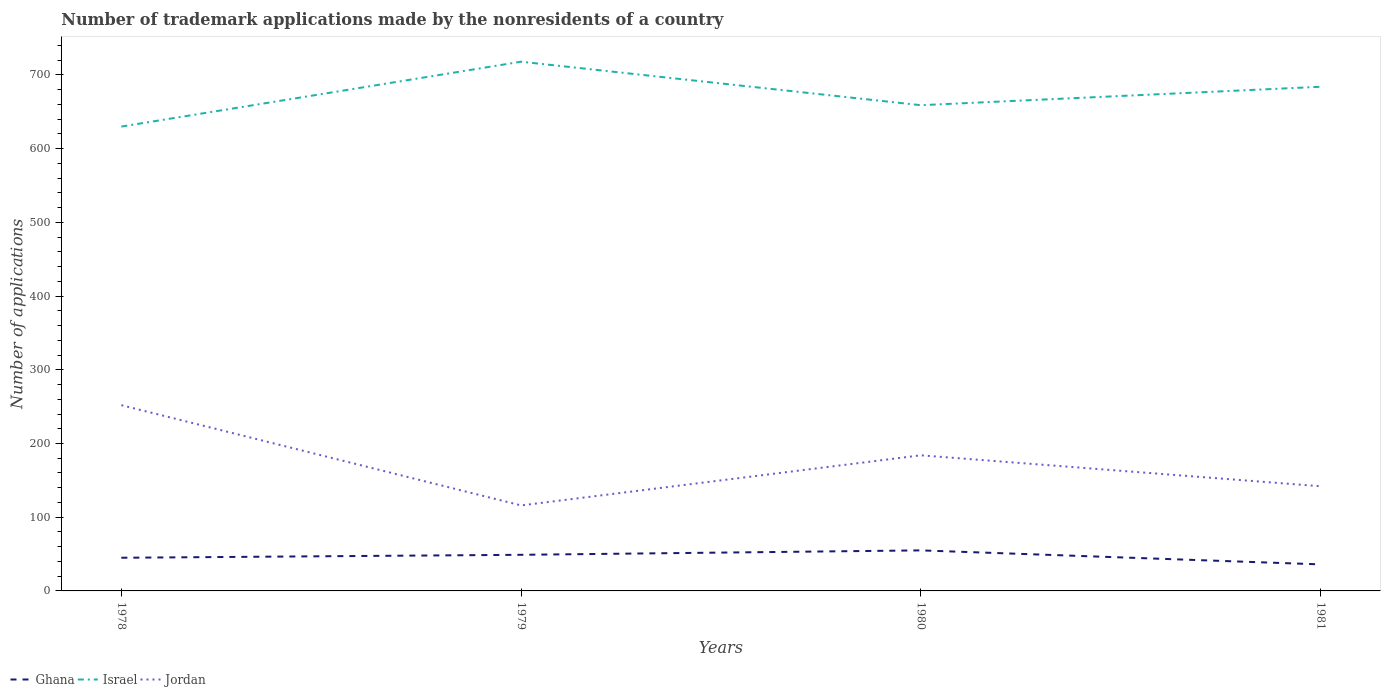How many different coloured lines are there?
Your answer should be compact. 3. Is the number of lines equal to the number of legend labels?
Give a very brief answer. Yes. In which year was the number of trademark applications made by the nonresidents in Israel maximum?
Give a very brief answer. 1978. What is the total number of trademark applications made by the nonresidents in Jordan in the graph?
Provide a short and direct response. -68. What is the difference between the highest and the lowest number of trademark applications made by the nonresidents in Ghana?
Offer a very short reply. 2. Is the number of trademark applications made by the nonresidents in Jordan strictly greater than the number of trademark applications made by the nonresidents in Ghana over the years?
Offer a terse response. No. How many lines are there?
Provide a short and direct response. 3. What is the difference between two consecutive major ticks on the Y-axis?
Your answer should be compact. 100. Does the graph contain any zero values?
Your answer should be very brief. No. Where does the legend appear in the graph?
Your answer should be very brief. Bottom left. What is the title of the graph?
Your response must be concise. Number of trademark applications made by the nonresidents of a country. What is the label or title of the Y-axis?
Provide a short and direct response. Number of applications. What is the Number of applications of Israel in 1978?
Your answer should be compact. 630. What is the Number of applications in Jordan in 1978?
Keep it short and to the point. 252. What is the Number of applications in Israel in 1979?
Your response must be concise. 718. What is the Number of applications in Jordan in 1979?
Keep it short and to the point. 116. What is the Number of applications in Israel in 1980?
Your answer should be very brief. 659. What is the Number of applications of Jordan in 1980?
Give a very brief answer. 184. What is the Number of applications in Israel in 1981?
Offer a terse response. 684. What is the Number of applications of Jordan in 1981?
Your response must be concise. 142. Across all years, what is the maximum Number of applications in Ghana?
Provide a short and direct response. 55. Across all years, what is the maximum Number of applications in Israel?
Keep it short and to the point. 718. Across all years, what is the maximum Number of applications in Jordan?
Provide a succinct answer. 252. Across all years, what is the minimum Number of applications in Israel?
Offer a terse response. 630. Across all years, what is the minimum Number of applications in Jordan?
Your answer should be very brief. 116. What is the total Number of applications in Ghana in the graph?
Provide a succinct answer. 185. What is the total Number of applications of Israel in the graph?
Your response must be concise. 2691. What is the total Number of applications of Jordan in the graph?
Offer a very short reply. 694. What is the difference between the Number of applications in Israel in 1978 and that in 1979?
Keep it short and to the point. -88. What is the difference between the Number of applications in Jordan in 1978 and that in 1979?
Your response must be concise. 136. What is the difference between the Number of applications in Ghana in 1978 and that in 1980?
Provide a short and direct response. -10. What is the difference between the Number of applications of Israel in 1978 and that in 1980?
Ensure brevity in your answer.  -29. What is the difference between the Number of applications of Israel in 1978 and that in 1981?
Your response must be concise. -54. What is the difference between the Number of applications in Jordan in 1978 and that in 1981?
Keep it short and to the point. 110. What is the difference between the Number of applications in Israel in 1979 and that in 1980?
Keep it short and to the point. 59. What is the difference between the Number of applications in Jordan in 1979 and that in 1980?
Make the answer very short. -68. What is the difference between the Number of applications in Ghana in 1979 and that in 1981?
Give a very brief answer. 13. What is the difference between the Number of applications in Israel in 1979 and that in 1981?
Your response must be concise. 34. What is the difference between the Number of applications of Jordan in 1979 and that in 1981?
Your answer should be compact. -26. What is the difference between the Number of applications in Ghana in 1978 and the Number of applications in Israel in 1979?
Give a very brief answer. -673. What is the difference between the Number of applications of Ghana in 1978 and the Number of applications of Jordan in 1979?
Your answer should be very brief. -71. What is the difference between the Number of applications of Israel in 1978 and the Number of applications of Jordan in 1979?
Your answer should be compact. 514. What is the difference between the Number of applications of Ghana in 1978 and the Number of applications of Israel in 1980?
Give a very brief answer. -614. What is the difference between the Number of applications in Ghana in 1978 and the Number of applications in Jordan in 1980?
Ensure brevity in your answer.  -139. What is the difference between the Number of applications in Israel in 1978 and the Number of applications in Jordan in 1980?
Offer a very short reply. 446. What is the difference between the Number of applications in Ghana in 1978 and the Number of applications in Israel in 1981?
Your answer should be compact. -639. What is the difference between the Number of applications of Ghana in 1978 and the Number of applications of Jordan in 1981?
Your response must be concise. -97. What is the difference between the Number of applications of Israel in 1978 and the Number of applications of Jordan in 1981?
Give a very brief answer. 488. What is the difference between the Number of applications in Ghana in 1979 and the Number of applications in Israel in 1980?
Give a very brief answer. -610. What is the difference between the Number of applications of Ghana in 1979 and the Number of applications of Jordan in 1980?
Ensure brevity in your answer.  -135. What is the difference between the Number of applications of Israel in 1979 and the Number of applications of Jordan in 1980?
Give a very brief answer. 534. What is the difference between the Number of applications in Ghana in 1979 and the Number of applications in Israel in 1981?
Offer a terse response. -635. What is the difference between the Number of applications of Ghana in 1979 and the Number of applications of Jordan in 1981?
Your answer should be compact. -93. What is the difference between the Number of applications of Israel in 1979 and the Number of applications of Jordan in 1981?
Give a very brief answer. 576. What is the difference between the Number of applications of Ghana in 1980 and the Number of applications of Israel in 1981?
Ensure brevity in your answer.  -629. What is the difference between the Number of applications of Ghana in 1980 and the Number of applications of Jordan in 1981?
Your answer should be compact. -87. What is the difference between the Number of applications in Israel in 1980 and the Number of applications in Jordan in 1981?
Ensure brevity in your answer.  517. What is the average Number of applications in Ghana per year?
Give a very brief answer. 46.25. What is the average Number of applications in Israel per year?
Offer a very short reply. 672.75. What is the average Number of applications of Jordan per year?
Your response must be concise. 173.5. In the year 1978, what is the difference between the Number of applications of Ghana and Number of applications of Israel?
Your response must be concise. -585. In the year 1978, what is the difference between the Number of applications of Ghana and Number of applications of Jordan?
Provide a short and direct response. -207. In the year 1978, what is the difference between the Number of applications of Israel and Number of applications of Jordan?
Make the answer very short. 378. In the year 1979, what is the difference between the Number of applications in Ghana and Number of applications in Israel?
Offer a terse response. -669. In the year 1979, what is the difference between the Number of applications of Ghana and Number of applications of Jordan?
Provide a succinct answer. -67. In the year 1979, what is the difference between the Number of applications of Israel and Number of applications of Jordan?
Provide a succinct answer. 602. In the year 1980, what is the difference between the Number of applications of Ghana and Number of applications of Israel?
Provide a succinct answer. -604. In the year 1980, what is the difference between the Number of applications of Ghana and Number of applications of Jordan?
Give a very brief answer. -129. In the year 1980, what is the difference between the Number of applications of Israel and Number of applications of Jordan?
Give a very brief answer. 475. In the year 1981, what is the difference between the Number of applications in Ghana and Number of applications in Israel?
Provide a short and direct response. -648. In the year 1981, what is the difference between the Number of applications in Ghana and Number of applications in Jordan?
Ensure brevity in your answer.  -106. In the year 1981, what is the difference between the Number of applications of Israel and Number of applications of Jordan?
Your answer should be compact. 542. What is the ratio of the Number of applications in Ghana in 1978 to that in 1979?
Your response must be concise. 0.92. What is the ratio of the Number of applications of Israel in 1978 to that in 1979?
Ensure brevity in your answer.  0.88. What is the ratio of the Number of applications of Jordan in 1978 to that in 1979?
Provide a short and direct response. 2.17. What is the ratio of the Number of applications in Ghana in 1978 to that in 1980?
Your response must be concise. 0.82. What is the ratio of the Number of applications in Israel in 1978 to that in 1980?
Provide a short and direct response. 0.96. What is the ratio of the Number of applications of Jordan in 1978 to that in 1980?
Your answer should be very brief. 1.37. What is the ratio of the Number of applications in Israel in 1978 to that in 1981?
Offer a terse response. 0.92. What is the ratio of the Number of applications of Jordan in 1978 to that in 1981?
Provide a short and direct response. 1.77. What is the ratio of the Number of applications of Ghana in 1979 to that in 1980?
Make the answer very short. 0.89. What is the ratio of the Number of applications in Israel in 1979 to that in 1980?
Provide a short and direct response. 1.09. What is the ratio of the Number of applications in Jordan in 1979 to that in 1980?
Ensure brevity in your answer.  0.63. What is the ratio of the Number of applications in Ghana in 1979 to that in 1981?
Provide a short and direct response. 1.36. What is the ratio of the Number of applications in Israel in 1979 to that in 1981?
Make the answer very short. 1.05. What is the ratio of the Number of applications of Jordan in 1979 to that in 1981?
Make the answer very short. 0.82. What is the ratio of the Number of applications in Ghana in 1980 to that in 1981?
Your response must be concise. 1.53. What is the ratio of the Number of applications of Israel in 1980 to that in 1981?
Give a very brief answer. 0.96. What is the ratio of the Number of applications of Jordan in 1980 to that in 1981?
Your response must be concise. 1.3. What is the difference between the highest and the second highest Number of applications in Israel?
Your response must be concise. 34. What is the difference between the highest and the second highest Number of applications in Jordan?
Make the answer very short. 68. What is the difference between the highest and the lowest Number of applications in Ghana?
Offer a very short reply. 19. What is the difference between the highest and the lowest Number of applications in Israel?
Ensure brevity in your answer.  88. What is the difference between the highest and the lowest Number of applications of Jordan?
Your answer should be compact. 136. 